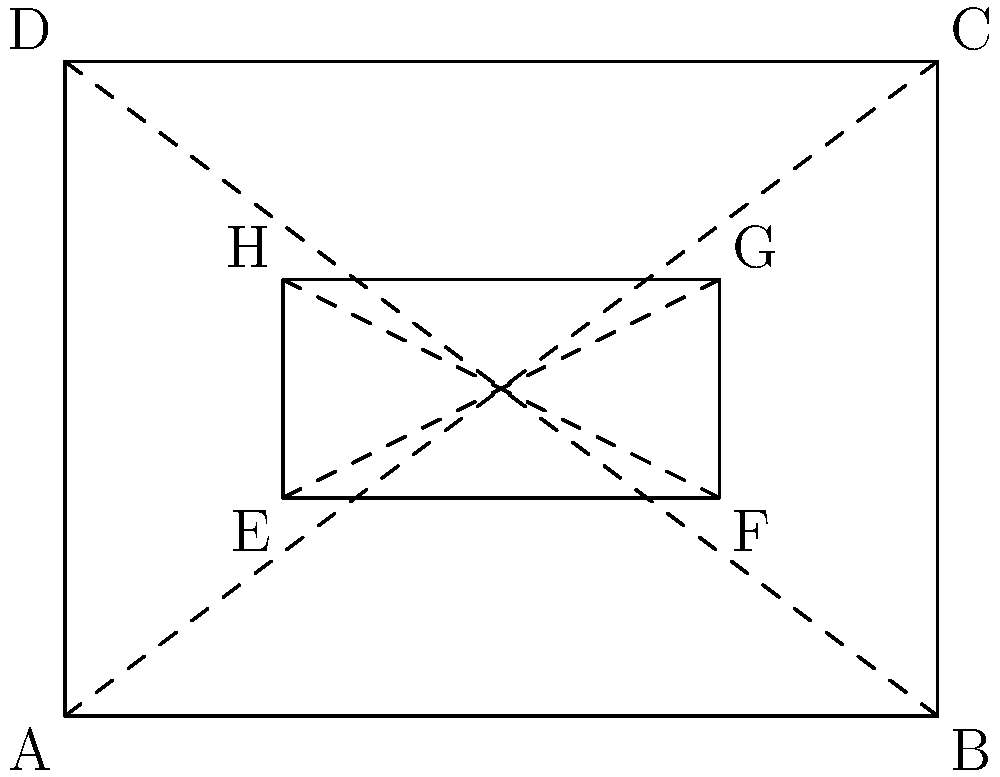In a virtual reality headset design, you need to identify congruent shapes to optimize the display. Given the rectangular frame ABCD and the inner rectangle EFGH, which transformation would map EFGH onto a congruent shape within ABCD? To determine the transformation that maps EFGH onto a congruent shape within ABCD, let's follow these steps:

1) First, observe that EFGH is a smaller rectangle inside ABCD.

2) The diagonals of both rectangles are drawn (AC, BD for ABCD and EG, FH for EFGH).

3) Notice that the diagonals intersect at the center of each rectangle.

4) The ratio of the sides of EFGH to ABCD appears to be 1:2.

5) This suggests that EFGH could be mapped onto any of the four quadrants of ABCD formed by its diagonals.

6) The transformation that would map EFGH onto a congruent shape in ABCD would be a combination of translation and rotation.

7) Specifically, EFGH could be translated to any of the other three quadrants of ABCD.

8) If moved to the opposite quadrant, it would require a 180° rotation around the center of ABCD.

9) If moved to an adjacent quadrant, it would require a 90° rotation (either clockwise or counterclockwise) around the center of ABCD.

Therefore, the transformation is a combination of translation and rotation, centered at the intersection of AC and BD.
Answer: Translation and rotation 